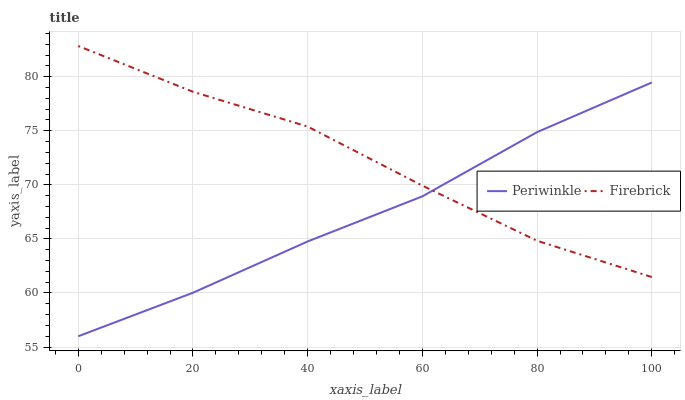Does Periwinkle have the maximum area under the curve?
Answer yes or no. No. Is Periwinkle the roughest?
Answer yes or no. No. Does Periwinkle have the highest value?
Answer yes or no. No. 